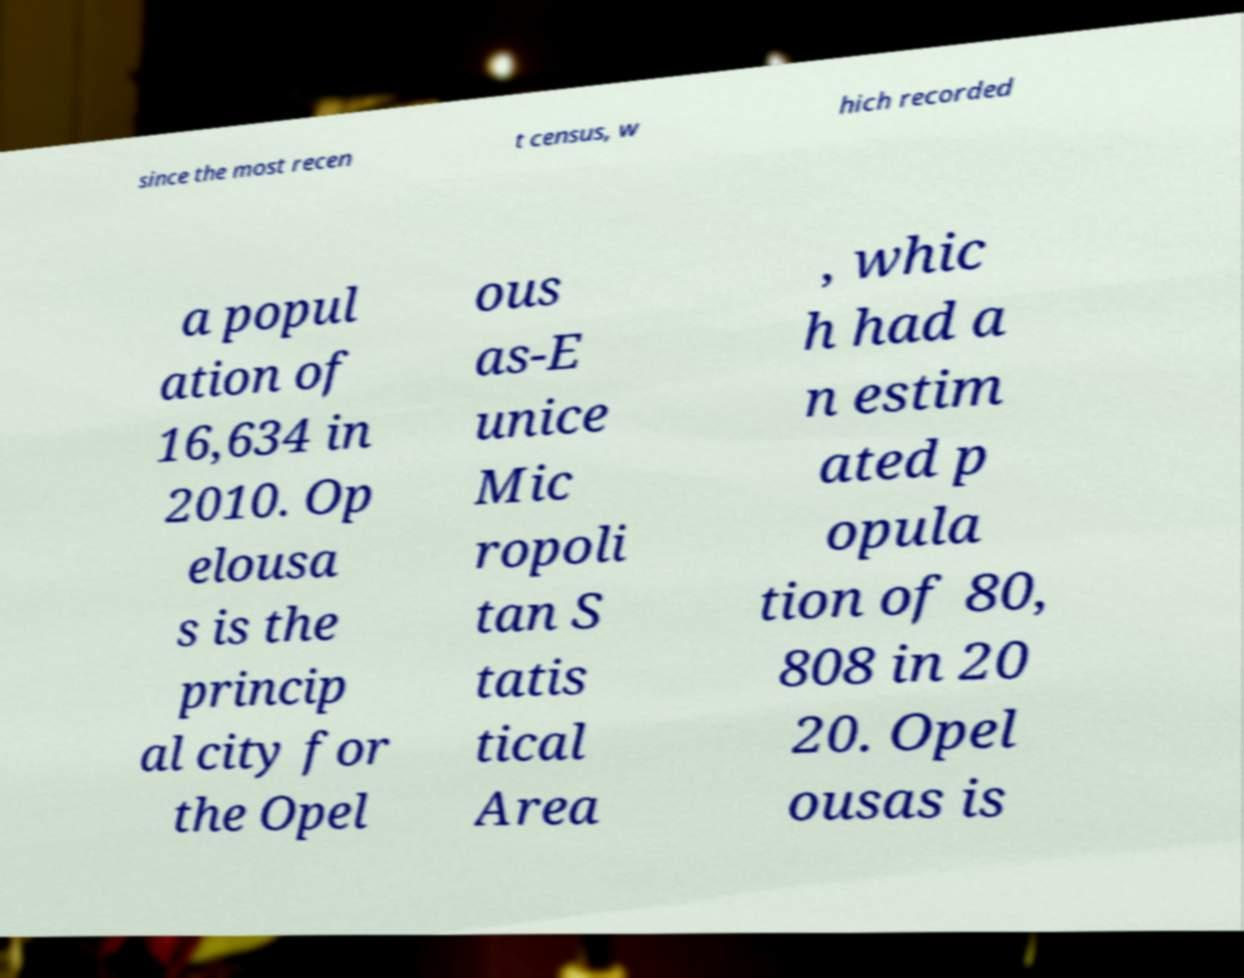What messages or text are displayed in this image? I need them in a readable, typed format. since the most recen t census, w hich recorded a popul ation of 16,634 in 2010. Op elousa s is the princip al city for the Opel ous as-E unice Mic ropoli tan S tatis tical Area , whic h had a n estim ated p opula tion of 80, 808 in 20 20. Opel ousas is 